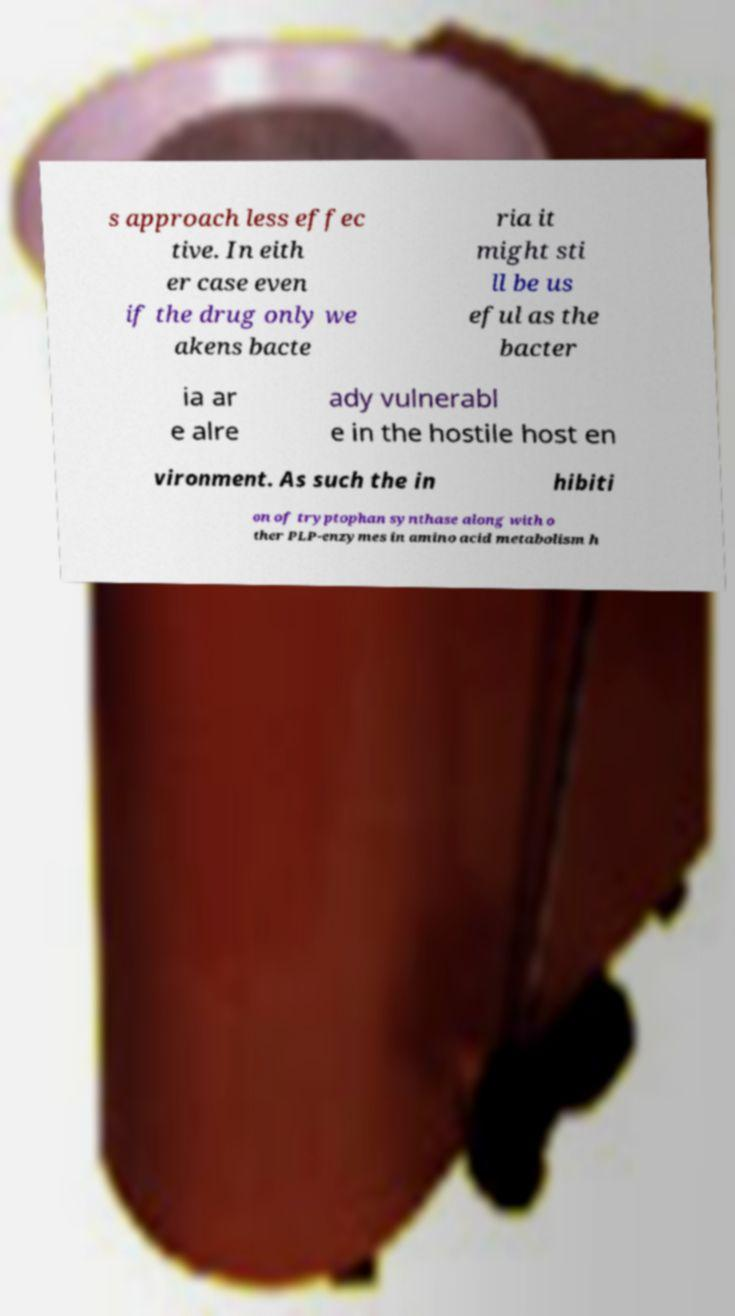For documentation purposes, I need the text within this image transcribed. Could you provide that? s approach less effec tive. In eith er case even if the drug only we akens bacte ria it might sti ll be us eful as the bacter ia ar e alre ady vulnerabl e in the hostile host en vironment. As such the in hibiti on of tryptophan synthase along with o ther PLP-enzymes in amino acid metabolism h 